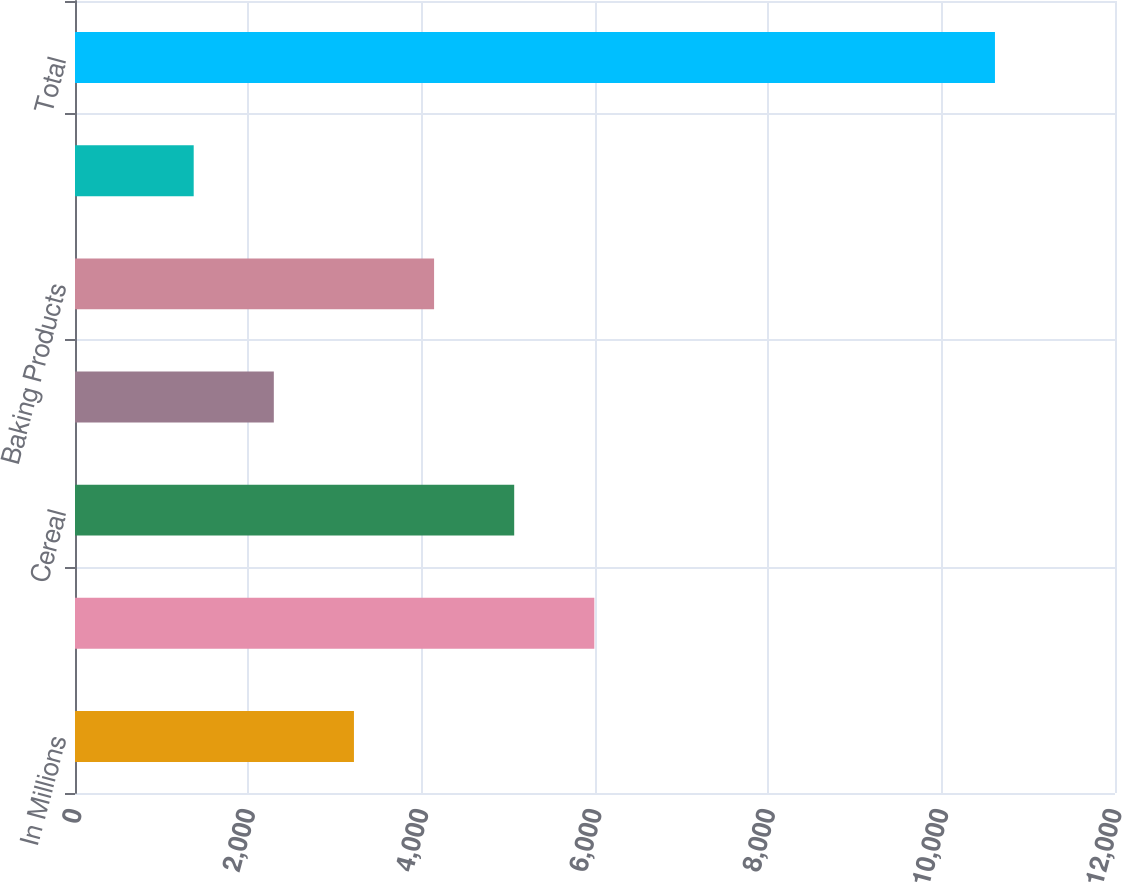Convert chart to OTSL. <chart><loc_0><loc_0><loc_500><loc_500><bar_chart><fcel>In Millions<fcel>Meals<fcel>Cereal<fcel>Snacks<fcel>Baking Products<fcel>Yogurt and other<fcel>Total<nl><fcel>3218.66<fcel>5992.25<fcel>5067.72<fcel>2294.13<fcel>4143.19<fcel>1369.6<fcel>10614.9<nl></chart> 